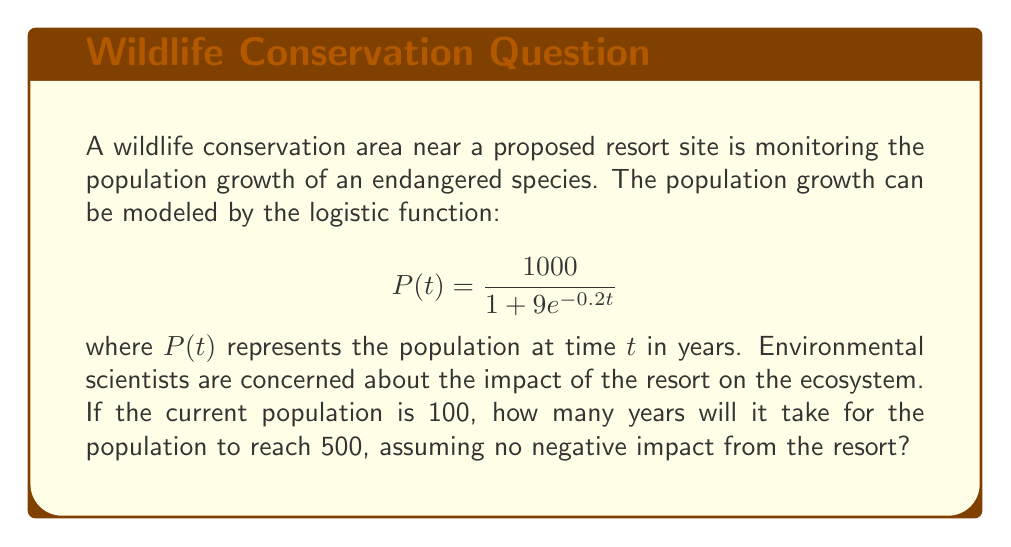Can you answer this question? To solve this problem, we need to use the given logistic function and find the value of $t$ when $P(t) = 500$. Let's break it down step-by-step:

1) We start with the equation:
   $$500 = \frac{1000}{1 + 9e^{-0.2t}}$$

2) Multiply both sides by $(1 + 9e^{-0.2t})$:
   $$500(1 + 9e^{-0.2t}) = 1000$$

3) Expand the left side:
   $$500 + 4500e^{-0.2t} = 1000$$

4) Subtract 500 from both sides:
   $$4500e^{-0.2t} = 500$$

5) Divide both sides by 4500:
   $$e^{-0.2t} = \frac{1}{9}$$

6) Take the natural log of both sides:
   $$-0.2t = \ln(\frac{1}{9})$$

7) Divide both sides by -0.2:
   $$t = -\frac{\ln(\frac{1}{9})}{0.2}$$

8) Simplify:
   $$t = \frac{\ln(9)}{0.2} \approx 11.0186$$

Therefore, it will take approximately 11.02 years for the population to reach 500, assuming no negative impact from the resort.
Answer: 11.02 years 